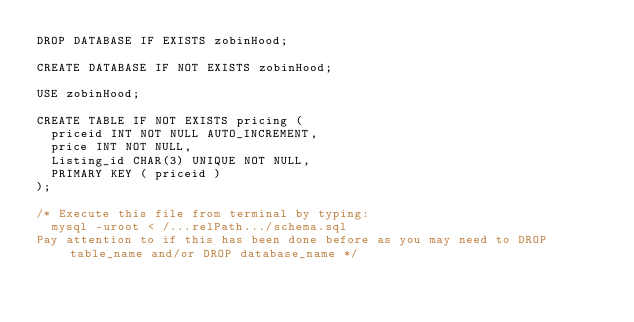<code> <loc_0><loc_0><loc_500><loc_500><_SQL_>DROP DATABASE IF EXISTS zobinHood;

CREATE DATABASE IF NOT EXISTS zobinHood;

USE zobinHood;

CREATE TABLE IF NOT EXISTS pricing (
	priceid INT NOT NULL AUTO_INCREMENT,
	price INT NOT NULL,
	Listing_id CHAR(3) UNIQUE NOT NULL,
	PRIMARY KEY ( priceid )
);

/* Execute this file from terminal by typing: 
	mysql -uroot < /...relPath.../schema.sql
Pay attention to if this has been done before as you may need to DROP table_name and/or DROP database_name */</code> 